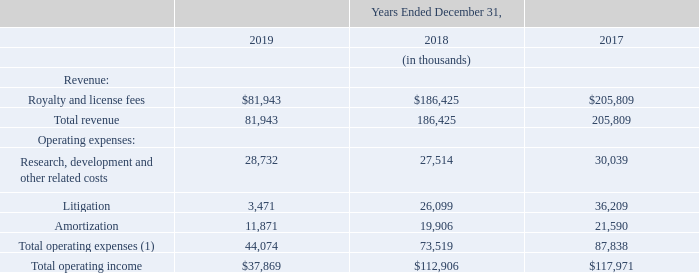Semiconductor and IP Licensing Segment
(1) Excludes operating expenses which are not allocated on a segment basis.
Semiconductor and IP Licensing segment revenue for the year ended December 31, 2019 was $81.9 million as compared to $186.4 million for the year ended December 31, 2018, a decrease of $104.5 million. The decrease in revenue was due principally to revenue recorded in 2018 related to the Samsung settlement and license agreement executed in December 2018, partially offset by a one-time payment from a new license agreement signed in December 2019.
What was the primary cause of the decrease in revenue in 2019 compared to 2018? Revenue recorded in 2018 related to the samsung settlement and license agreement executed in december 2018, partially offset by a one-time payment from a new license agreement signed in december 2019. What was the revenue change between 2018 and 2019? $104.5 million. What was the total operating expense in 2017 and 2018, respectively?
Answer scale should be: thousand. 73,519, 44,074. Which year did the Semiconductor and IP Licensing segment have the highest total operating income? 117,971>112,906>37,869
Answer: 2017. What is the percentage of research, development, and other related costs as well as litigation expenses over total operating expenses in 2018?
Answer scale should be: percent. (27,514+26,099)/73,519 
Answer: 72.92. What is the average revenue that the company received in the last three years, i.e. from 2017 to 2019?
Answer scale should be: thousand. (81,943+186,425+205,809)/3 
Answer: 158059. 